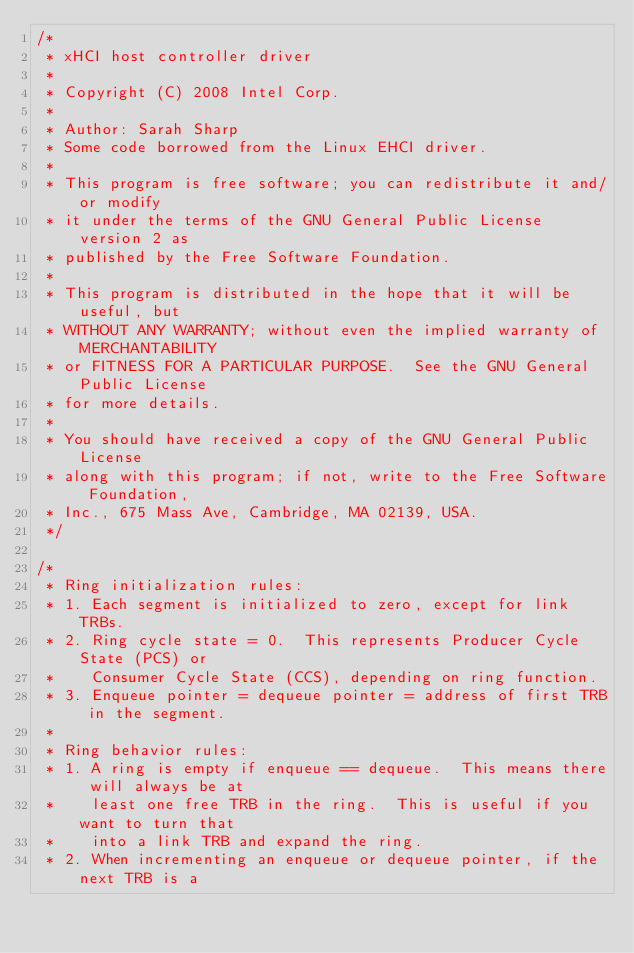Convert code to text. <code><loc_0><loc_0><loc_500><loc_500><_C_>/*
 * xHCI host controller driver
 *
 * Copyright (C) 2008 Intel Corp.
 *
 * Author: Sarah Sharp
 * Some code borrowed from the Linux EHCI driver.
 *
 * This program is free software; you can redistribute it and/or modify
 * it under the terms of the GNU General Public License version 2 as
 * published by the Free Software Foundation.
 *
 * This program is distributed in the hope that it will be useful, but
 * WITHOUT ANY WARRANTY; without even the implied warranty of MERCHANTABILITY
 * or FITNESS FOR A PARTICULAR PURPOSE.  See the GNU General Public License
 * for more details.
 *
 * You should have received a copy of the GNU General Public License
 * along with this program; if not, write to the Free Software Foundation,
 * Inc., 675 Mass Ave, Cambridge, MA 02139, USA.
 */

/*
 * Ring initialization rules:
 * 1. Each segment is initialized to zero, except for link TRBs.
 * 2. Ring cycle state = 0.  This represents Producer Cycle State (PCS) or
 *    Consumer Cycle State (CCS), depending on ring function.
 * 3. Enqueue pointer = dequeue pointer = address of first TRB in the segment.
 *
 * Ring behavior rules:
 * 1. A ring is empty if enqueue == dequeue.  This means there will always be at
 *    least one free TRB in the ring.  This is useful if you want to turn that
 *    into a link TRB and expand the ring.
 * 2. When incrementing an enqueue or dequeue pointer, if the next TRB is a</code> 